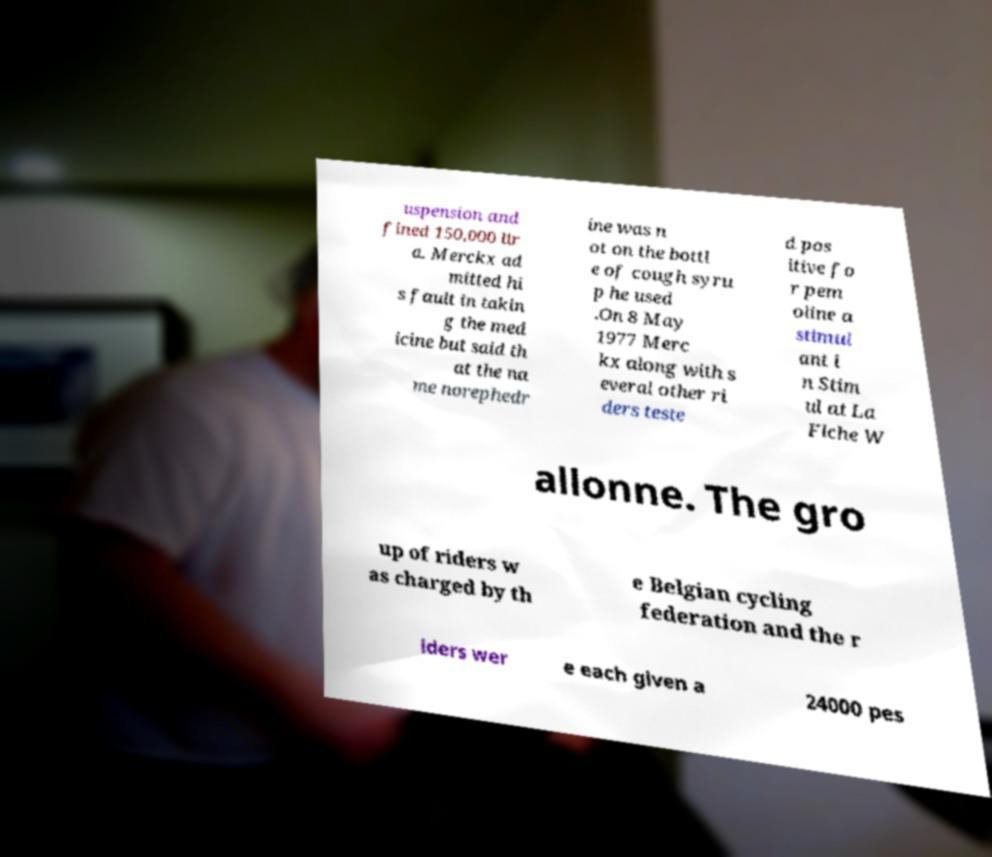There's text embedded in this image that I need extracted. Can you transcribe it verbatim? uspension and fined 150,000 lir a. Merckx ad mitted hi s fault in takin g the med icine but said th at the na me norephedr ine was n ot on the bottl e of cough syru p he used .On 8 May 1977 Merc kx along with s everal other ri ders teste d pos itive fo r pem oline a stimul ant i n Stim ul at La Flche W allonne. The gro up of riders w as charged by th e Belgian cycling federation and the r iders wer e each given a 24000 pes 